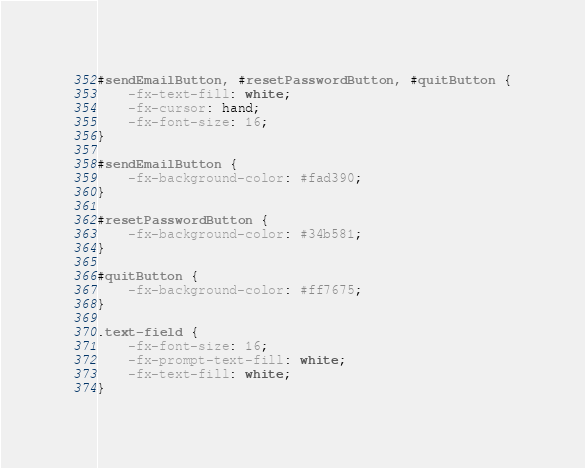Convert code to text. <code><loc_0><loc_0><loc_500><loc_500><_CSS_>#sendEmailButton, #resetPasswordButton, #quitButton {
    -fx-text-fill: white;
    -fx-cursor: hand;
    -fx-font-size: 16;
}

#sendEmailButton {
    -fx-background-color: #fad390;
}

#resetPasswordButton {
    -fx-background-color: #34b581;
}

#quitButton {
    -fx-background-color: #ff7675;
}

.text-field {
    -fx-font-size: 16;
    -fx-prompt-text-fill: white;
    -fx-text-fill: white;
}</code> 